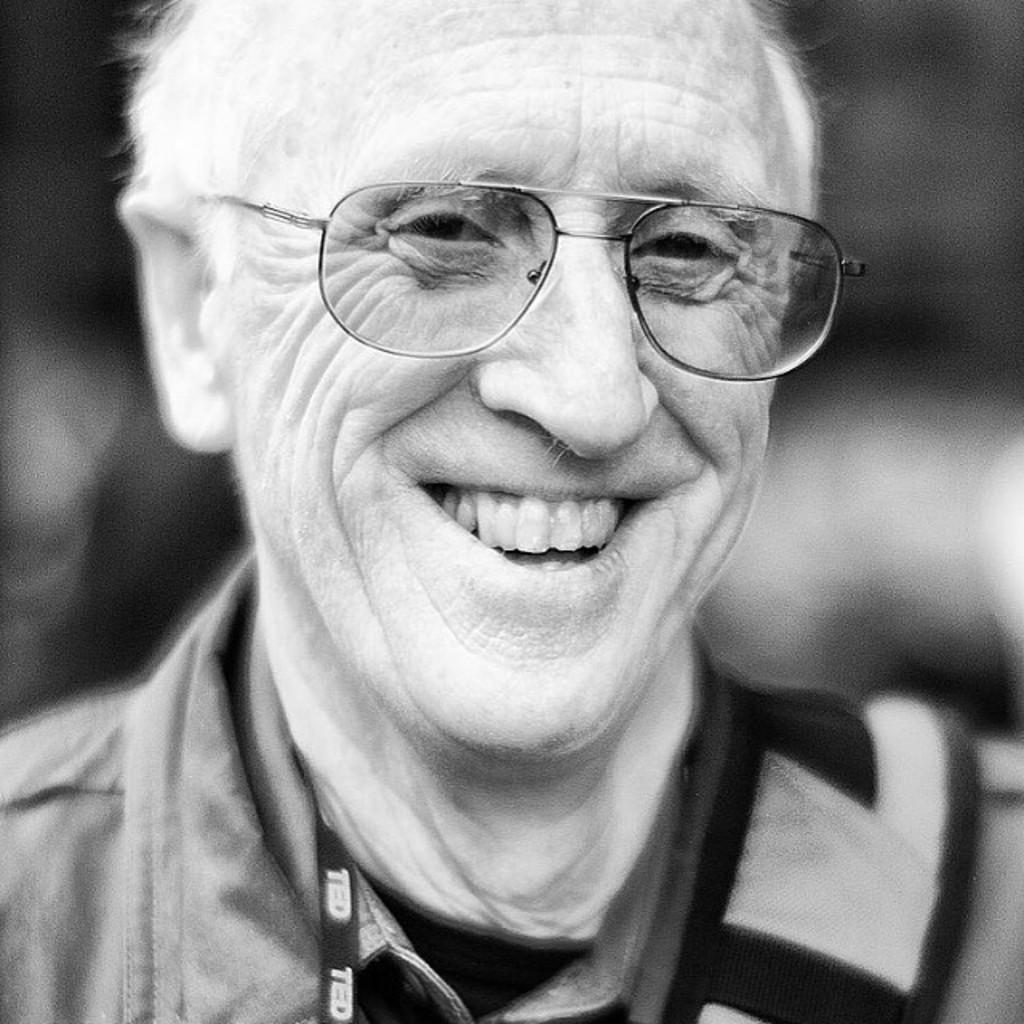Who is the main subject in the image? There is an old man in the image. What is the old man doing in the image? The old man is smiling. What accessories is the old man wearing in the image? The old man is wearing an ID card and spectacles. How would you describe the background of the image? The background of the image is blurred. What is the color scheme of the image? The image is black and white. What type of jeans is the old man wearing in the image? The image is black and white, and there is no mention of jeans in the provided facts, so it cannot be determined if the old man is wearing jeans or not. 